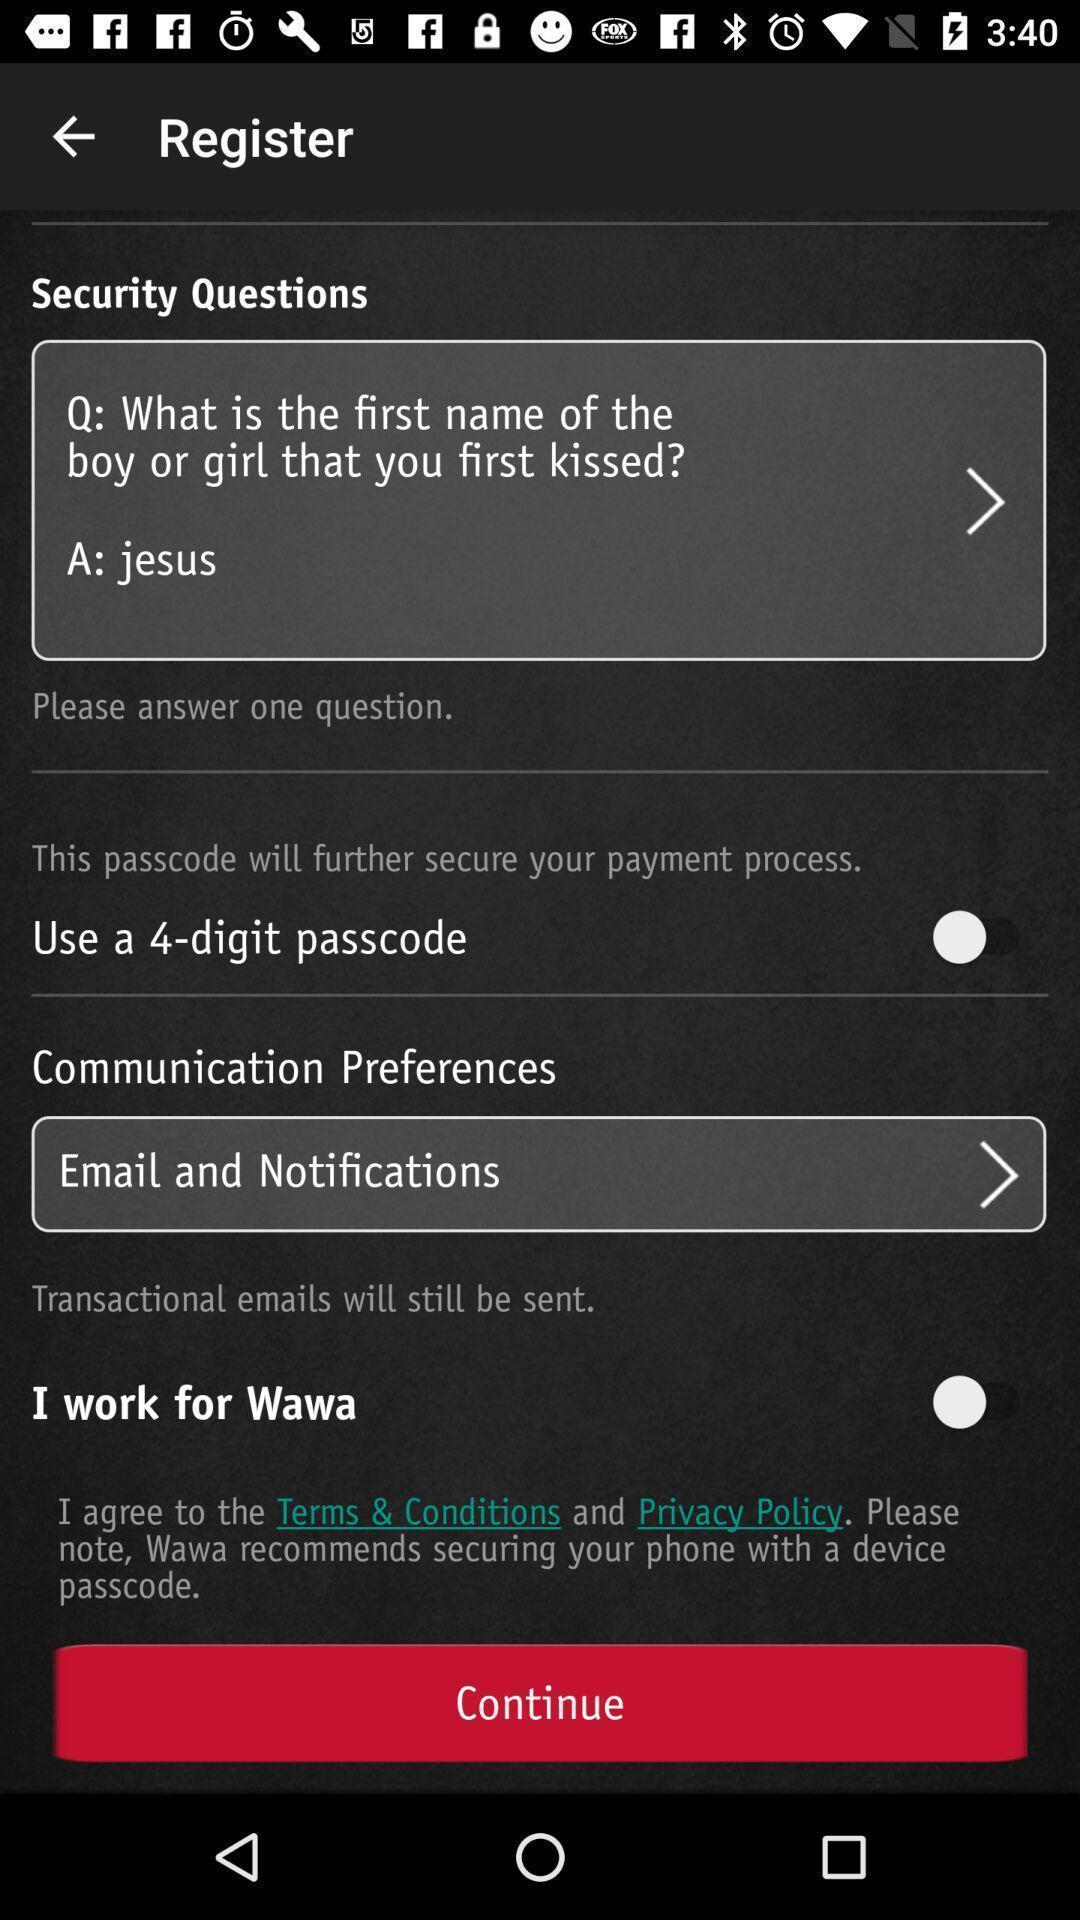Tell me what you see in this picture. Screen displaying registration page. 